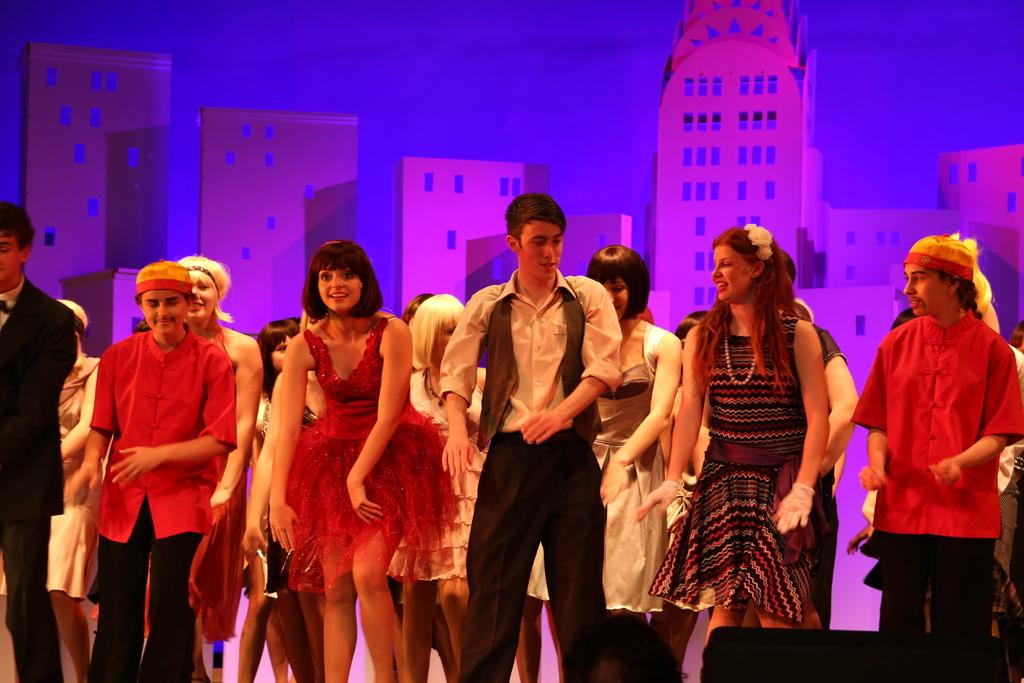What are the people in the image doing? The people in the image are dancing. What can be seen in the background of the image? There is a wallpaper with buildings in the background of the image. What type of beetle can be seen crawling on the wallpaper in the image? There is no beetle present in the image; the background features wallpaper with buildings. 